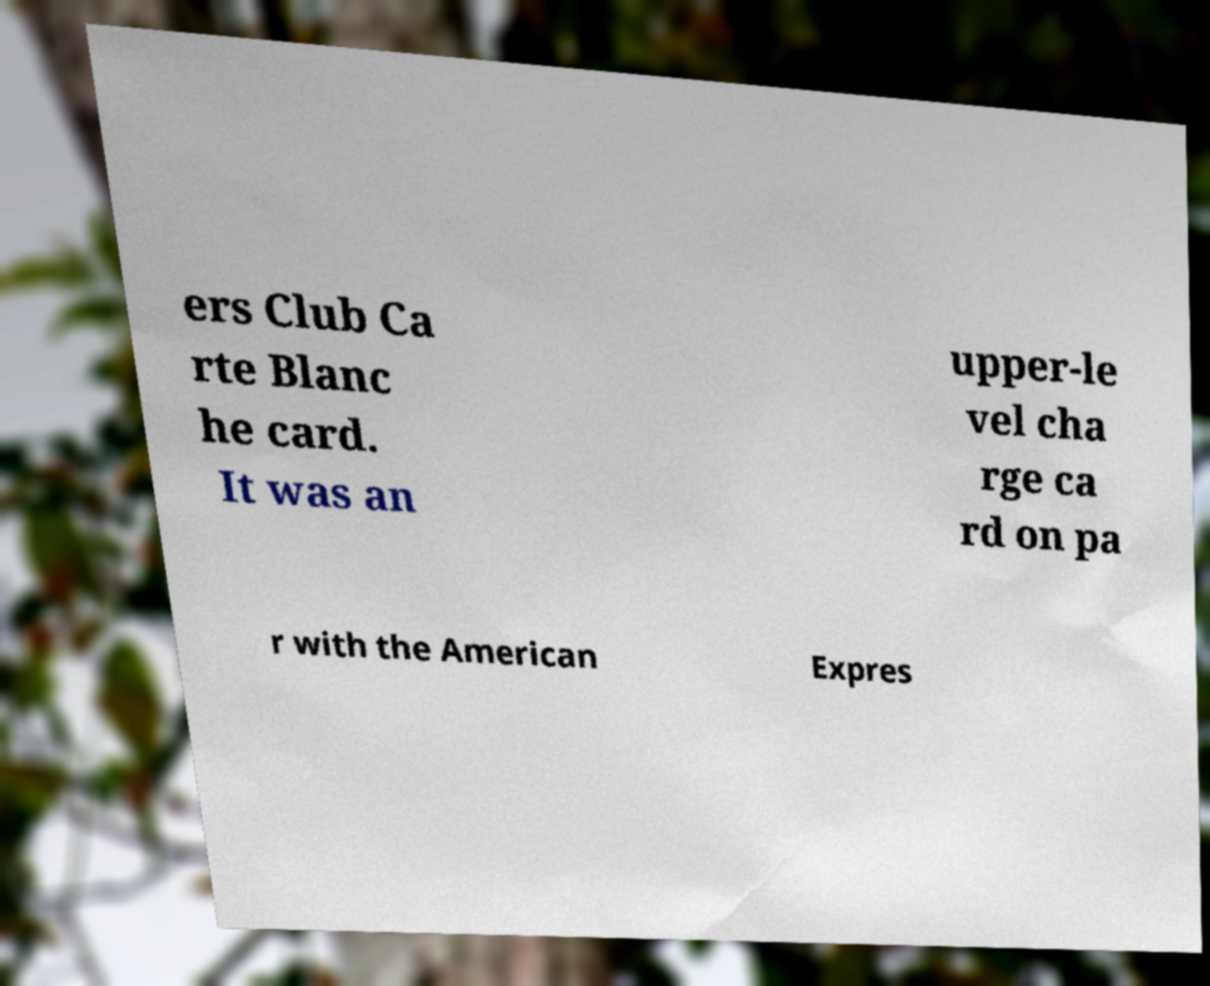For documentation purposes, I need the text within this image transcribed. Could you provide that? ers Club Ca rte Blanc he card. It was an upper-le vel cha rge ca rd on pa r with the American Expres 